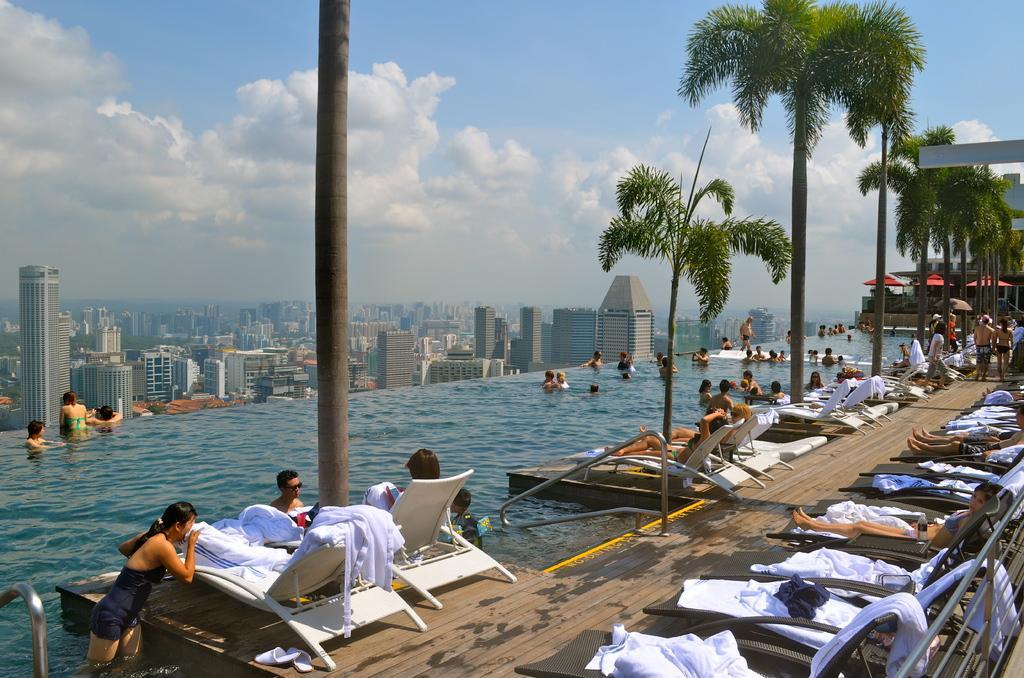Please provide a concise description of this image. In this image we can see a few people, among them some people are in the water and some people are sitting on chairs, there are some trees, buildings and huts, in the background we can see the sky. 